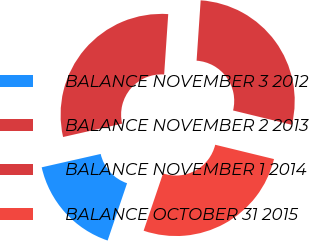Convert chart to OTSL. <chart><loc_0><loc_0><loc_500><loc_500><pie_chart><fcel>BALANCE NOVEMBER 3 2012<fcel>BALANCE NOVEMBER 2 2013<fcel>BALANCE NOVEMBER 1 2014<fcel>BALANCE OCTOBER 31 2015<nl><fcel>16.25%<fcel>29.62%<fcel>27.73%<fcel>26.4%<nl></chart> 